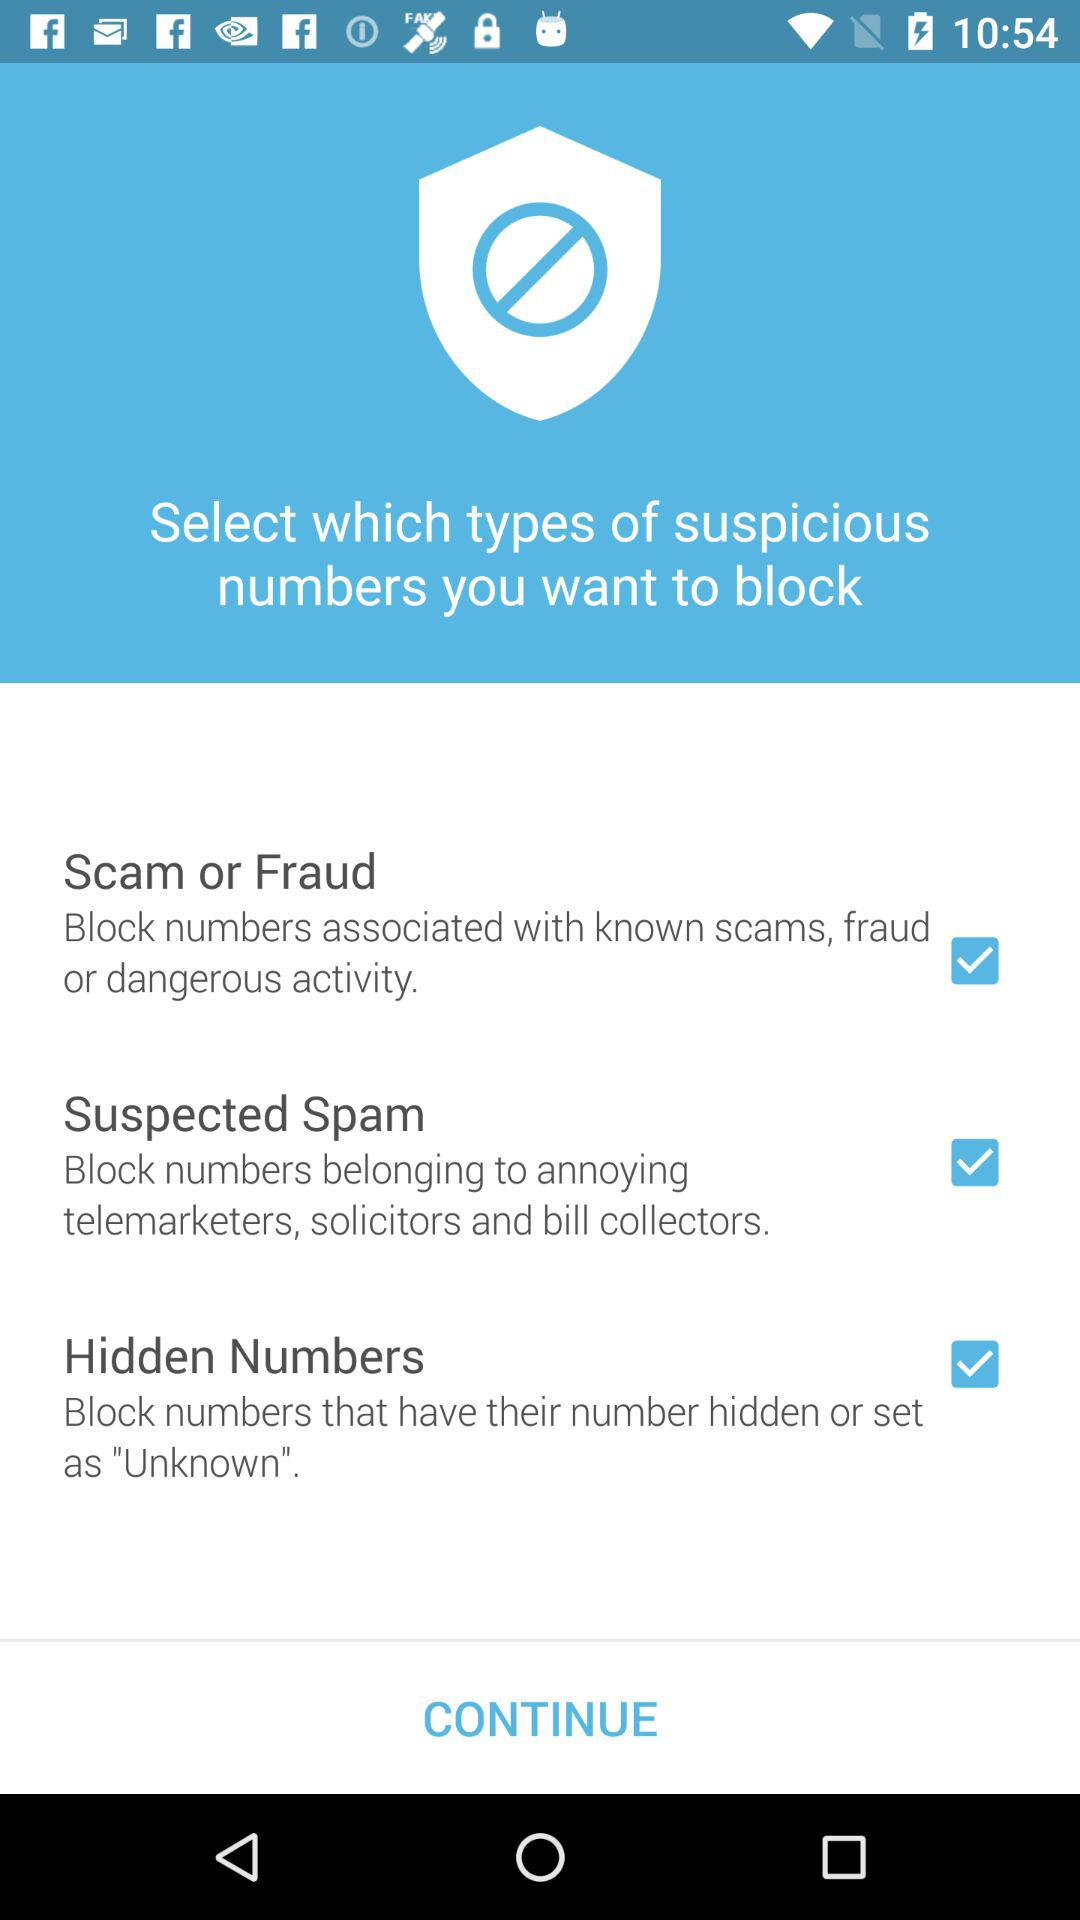What is the name of the application?
When the provided information is insufficient, respond with <no answer>. <no answer> 